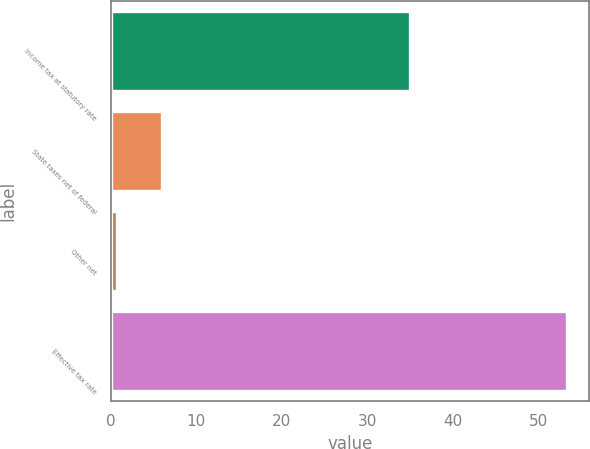<chart> <loc_0><loc_0><loc_500><loc_500><bar_chart><fcel>Income tax at statutory rate<fcel>State taxes net of federal<fcel>Other net<fcel>Effective tax rate<nl><fcel>35<fcel>6.05<fcel>0.8<fcel>53.3<nl></chart> 